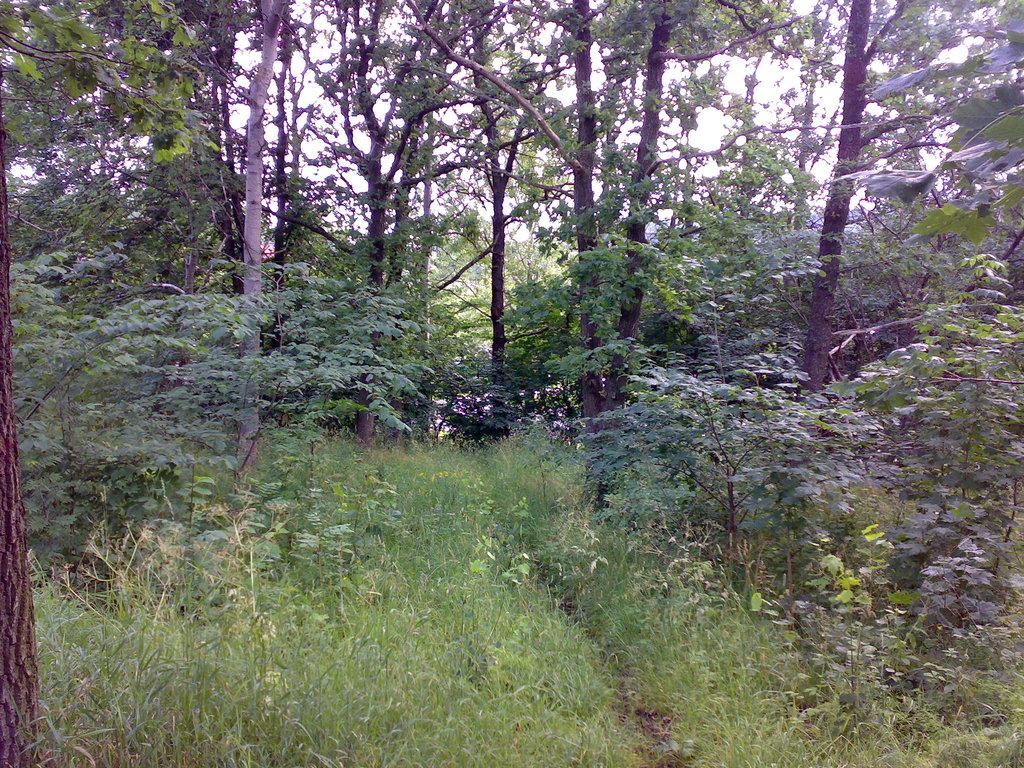What type of environment is shown in the image? The image depicts a forest. What are the main features of the forest? There are trees in the image. What can be seen above the trees in the image? The sky is visible at the top of the image. What type of vegetation is present at the bottom of the image? Grass is present at the bottom of the image. What effect does the hall have on the forest in the image? There is no hall present in the image, so it cannot have any effect on the forest. 